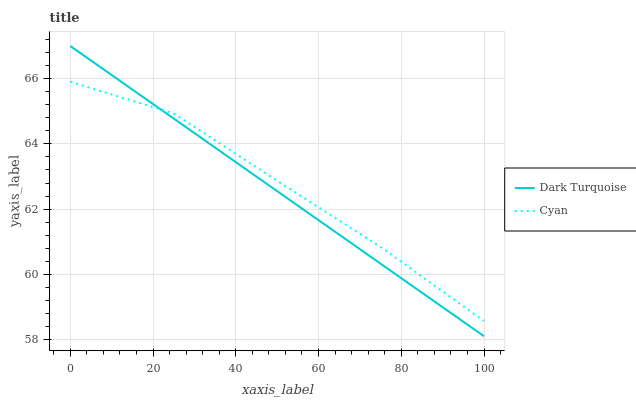Does Dark Turquoise have the minimum area under the curve?
Answer yes or no. Yes. Does Cyan have the maximum area under the curve?
Answer yes or no. Yes. Does Cyan have the minimum area under the curve?
Answer yes or no. No. Is Dark Turquoise the smoothest?
Answer yes or no. Yes. Is Cyan the roughest?
Answer yes or no. Yes. Is Cyan the smoothest?
Answer yes or no. No. Does Dark Turquoise have the lowest value?
Answer yes or no. Yes. Does Cyan have the lowest value?
Answer yes or no. No. Does Dark Turquoise have the highest value?
Answer yes or no. Yes. Does Cyan have the highest value?
Answer yes or no. No. Does Dark Turquoise intersect Cyan?
Answer yes or no. Yes. Is Dark Turquoise less than Cyan?
Answer yes or no. No. Is Dark Turquoise greater than Cyan?
Answer yes or no. No. 